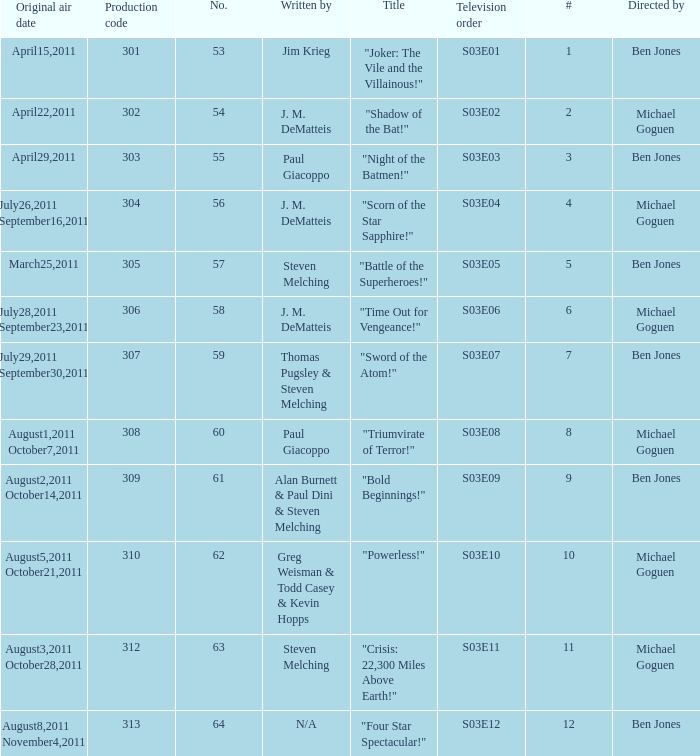What is the original air date of the episode directed by ben jones and written by steven melching?  March25,2011. 